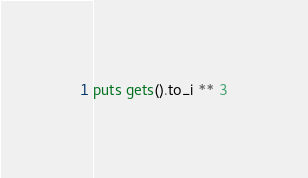Convert code to text. <code><loc_0><loc_0><loc_500><loc_500><_Ruby_>puts gets().to_i ** 3</code> 